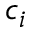Convert formula to latex. <formula><loc_0><loc_0><loc_500><loc_500>c _ { i }</formula> 